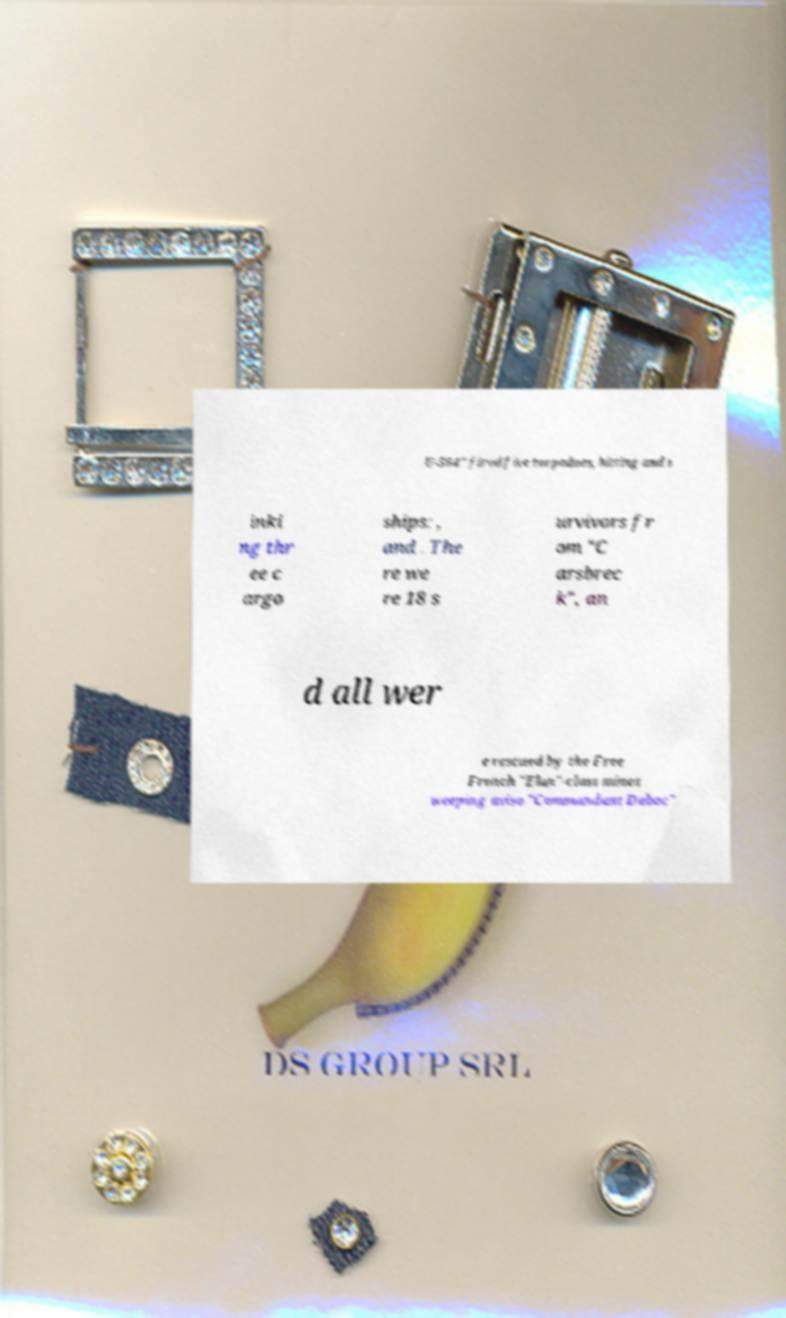Please read and relay the text visible in this image. What does it say? U-564" fired five torpedoes, hitting and s inki ng thr ee c argo ships: , and . The re we re 18 s urvivors fr om "C arsbrec k", an d all wer e rescued by the Free French "Elan"-class mines weeping aviso "Commandant Duboc" 